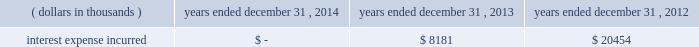Junior subordinated debt securities payable in accordance with the provisions of the junior subordinated debt securities which were issued on march 29 , 2004 , holdings elected to redeem the $ 329897 thousand of 6.2% ( 6.2 % ) junior subordinated debt securities outstanding on may 24 , 2013 .
As a result of the early redemption , the company incurred pre-tax expense of $ 7282 thousand related to the immediate amortization of the remaining capitalized issuance costs on the trust preferred securities .
Interest expense incurred in connection with these junior subordinated debt securities is as follows for the periods indicated: .
Holdings considered the mechanisms and obligations relating to the trust preferred securities , taken together , constituted a full and unconditional guarantee by holdings of capital trust ii 2019s payment obligations with respect to their trust preferred securities .
10 .
Reinsurance and trust agreements certain subsidiaries of group have established trust agreements , which effectively use the company 2019s investments as collateral , as security for assumed losses payable to certain non-affiliated ceding companies .
At december 31 , 2014 , the total amount on deposit in trust accounts was $ 322285 thousand .
On april 24 , 2014 , the company entered into two collateralized reinsurance agreements with kilimanjaro re limited ( 201ckilimanjaro 201d ) , a bermuda based special purpose reinsurer , to provide the company with catastrophe reinsurance coverage .
These agreements are multi-year reinsurance contracts which cover specified named storm and earthquake events .
The first agreement provides up to $ 250000 thousand of reinsurance coverage from named storms in specified states of the southeastern united states .
The second agreement provides up to $ 200000 thousand of reinsurance coverage from named storms in specified states of the southeast , mid-atlantic and northeast regions of the united states and puerto rico as well as reinsurance coverage from earthquakes in specified states of the southeast , mid-atlantic , northeast and west regions of the united states , puerto rico and british columbia .
On november 18 , 2014 , the company entered into a collateralized reinsurance agreement with kilimanjaro re to provide the company with catastrophe reinsurance coverage .
This agreement is a multi-year reinsurance contract which covers specified earthquake events .
The agreement provides up to $ 500000 thousand of reinsurance coverage from earthquakes in the united states , puerto rico and canada .
Kilimanjaro has financed the various property catastrophe reinsurance coverage by issuing catastrophe bonds to unrelated , external investors .
On april 24 , 2014 , kilimanjaro issued $ 450000 thousand of variable rate notes ( 201cseries 2014-1 notes 201d ) .
On november 18 , 2014 , kilimanjaro issued $ 500000 thousand of variable rate notes ( 201cseries 2014-2 notes 201d ) .
The proceeds from the issuance of the series 2014-1 notes and the series 2014-2 notes are held in reinsurance trust throughout the duration of the applicable reinsurance agreements and invested solely in us government money market funds with a rating of at least 201caaam 201d by standard & poor 2019s. .
What was the total reinsurance coverage secured in 2014 in thousands? 
Computations: (200000 + 250000)
Answer: 450000.0. 